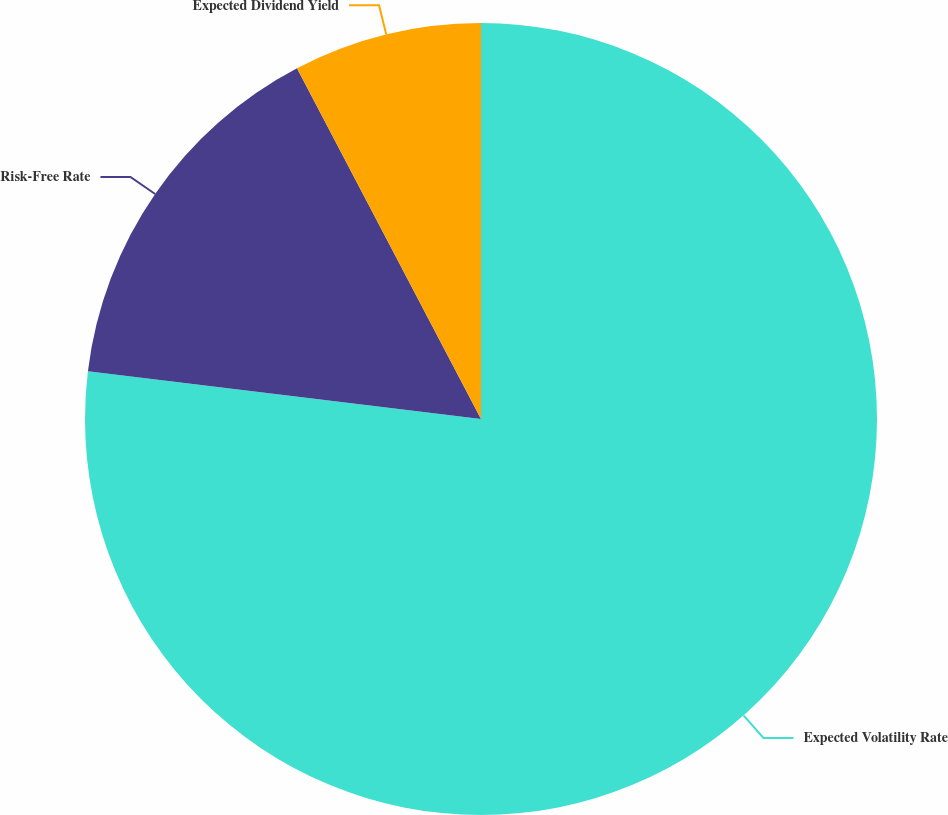Convert chart. <chart><loc_0><loc_0><loc_500><loc_500><pie_chart><fcel>Expected Volatility Rate<fcel>Risk-Free Rate<fcel>Expected Dividend Yield<nl><fcel>76.92%<fcel>15.38%<fcel>7.69%<nl></chart> 